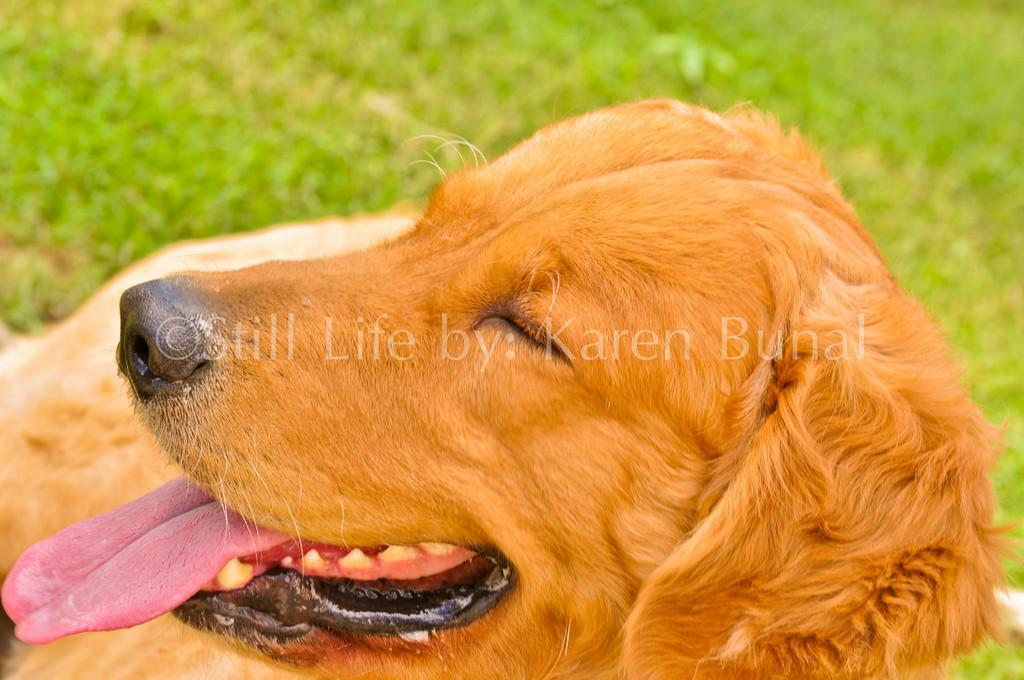What type of animal is in the image? There is a dog in the image. Is there any text associated with the dog? Yes, there is text visible on the dog. What is the ground surface like in the image? Grass is present on the ground in the image. What type of band is playing in the background of the image? There is no band present in the image; it only features a dog with text on it and grass on the ground. 